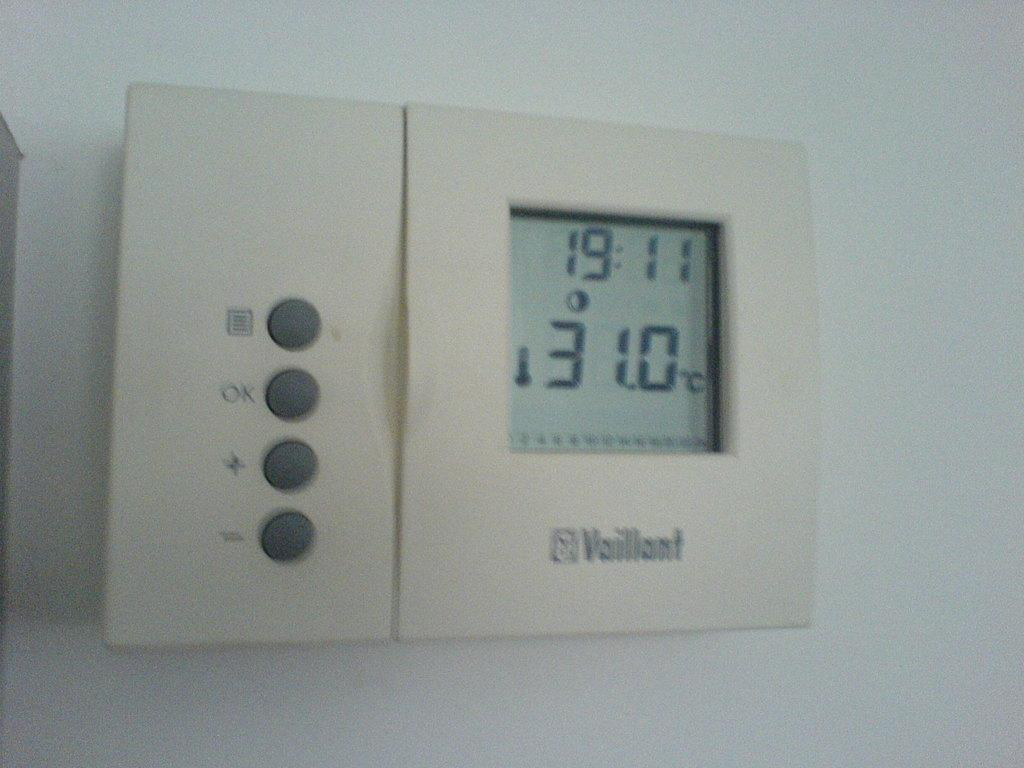<image>
Describe the image concisely. A Vaillant thermostat on the wall says 31.0 degrees 